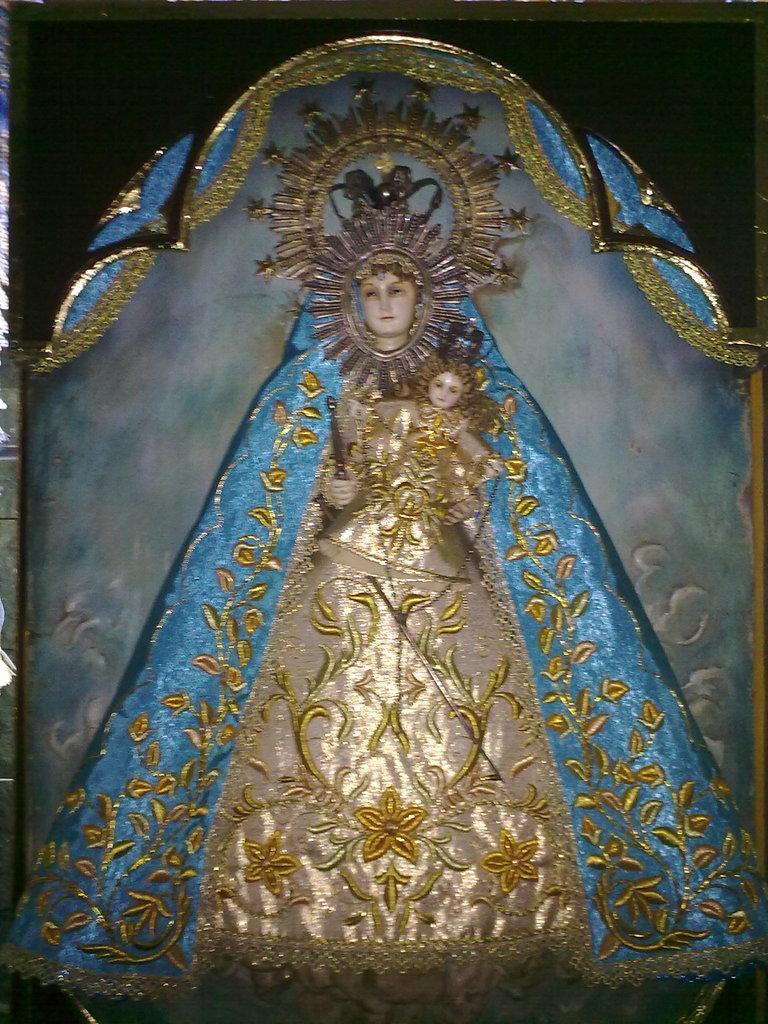Could you give a brief overview of what you see in this image? In this image I can see there is a statue of a woman holding the baby. It is covered with the blue and gold color clothes. 